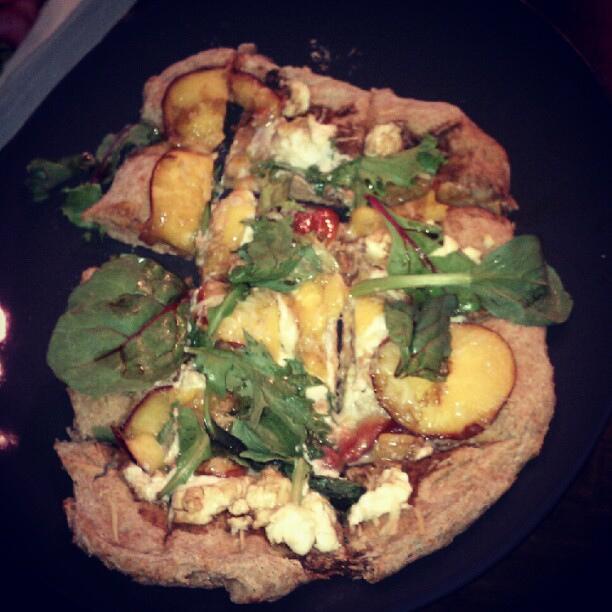Is this a vegetarian meal?
Write a very short answer. Yes. What is green in the picture?
Be succinct. Lettuce. Does the appear to be cooked?
Be succinct. Yes. 